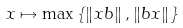Convert formula to latex. <formula><loc_0><loc_0><loc_500><loc_500>x \mapsto \max \left \{ \left \| x b \right \| , \left \| b x \right \| \right \}</formula> 